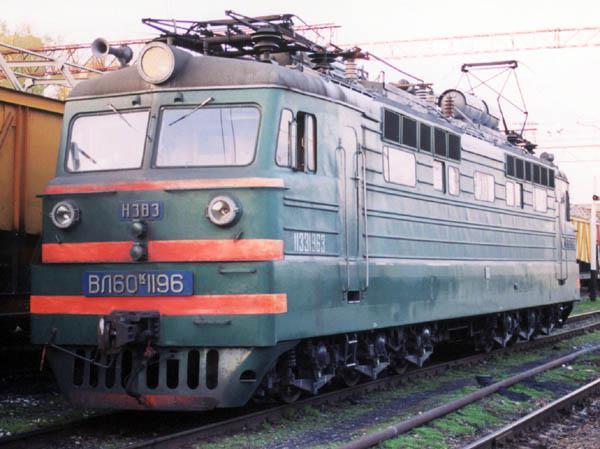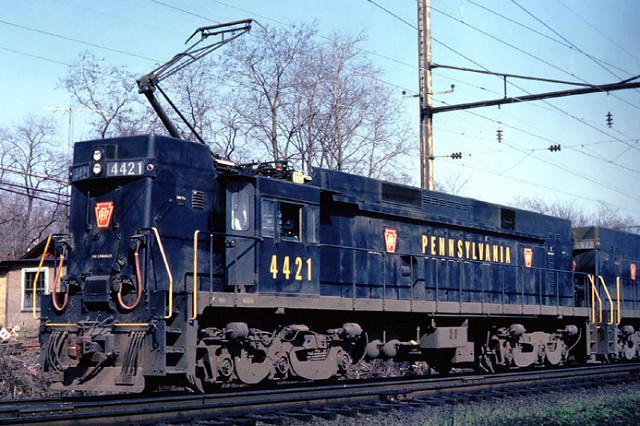The first image is the image on the left, the second image is the image on the right. Analyze the images presented: Is the assertion "The train engine in one of the images is bright red." valid? Answer yes or no. No. 